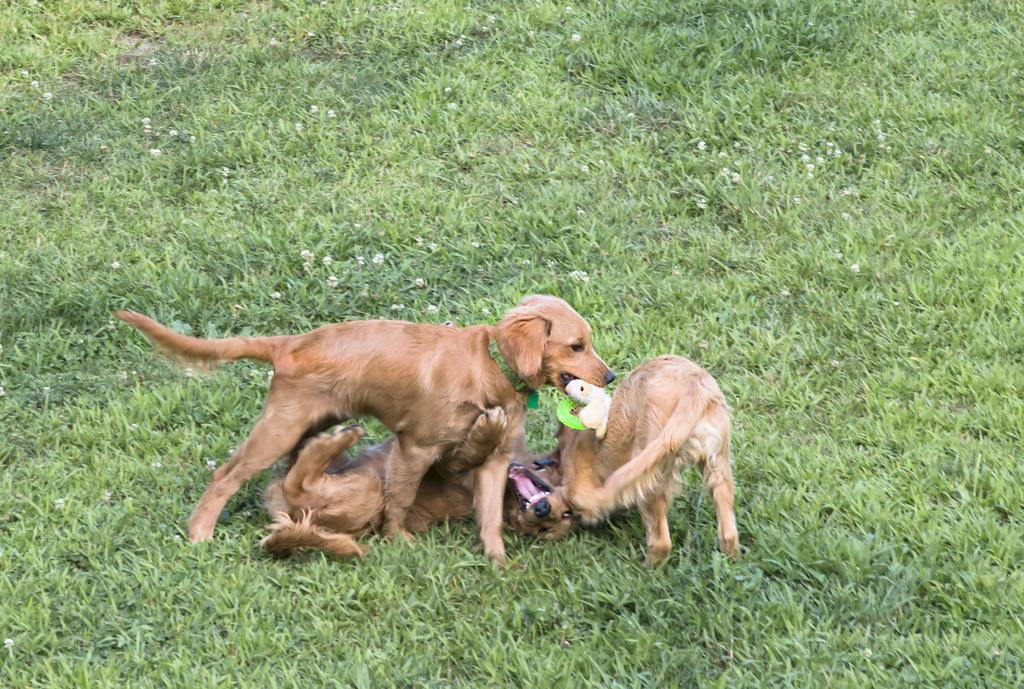How many dogs are present in the image? There are three dogs in the image. What are the dogs doing in the image? The dogs are playing in a grassland. Can you describe any objects in the image besides the dogs? Yes, there is a white toy in the image. Is there a crate visible in the image? No, there is no crate present in the image. What type of wilderness can be seen in the background of the image? The image does not depict any wilderness; it shows a grassland where the dogs are playing. 